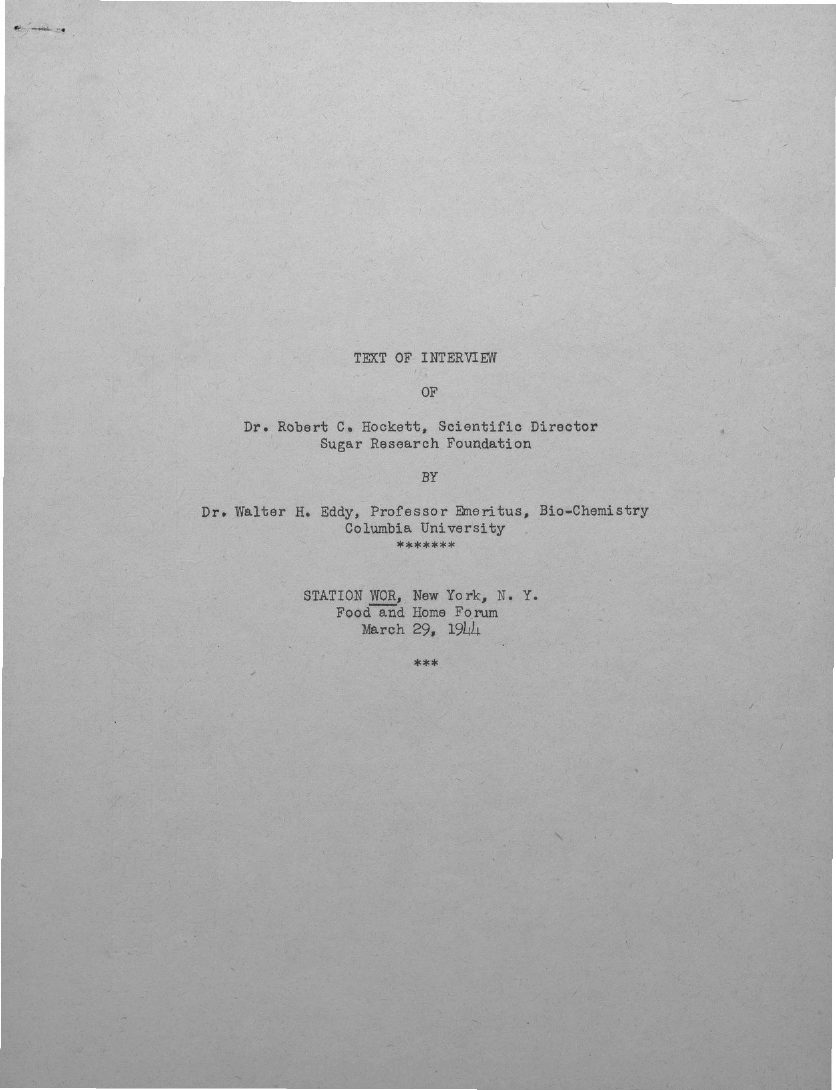What is the designation of Dr. Robert C. Hockett?
Ensure brevity in your answer.  Scientific Director. What is the designation of Dr. Walter H. Eddy?
Offer a terse response. Professor Emeritus, Bio-Chemistry. 